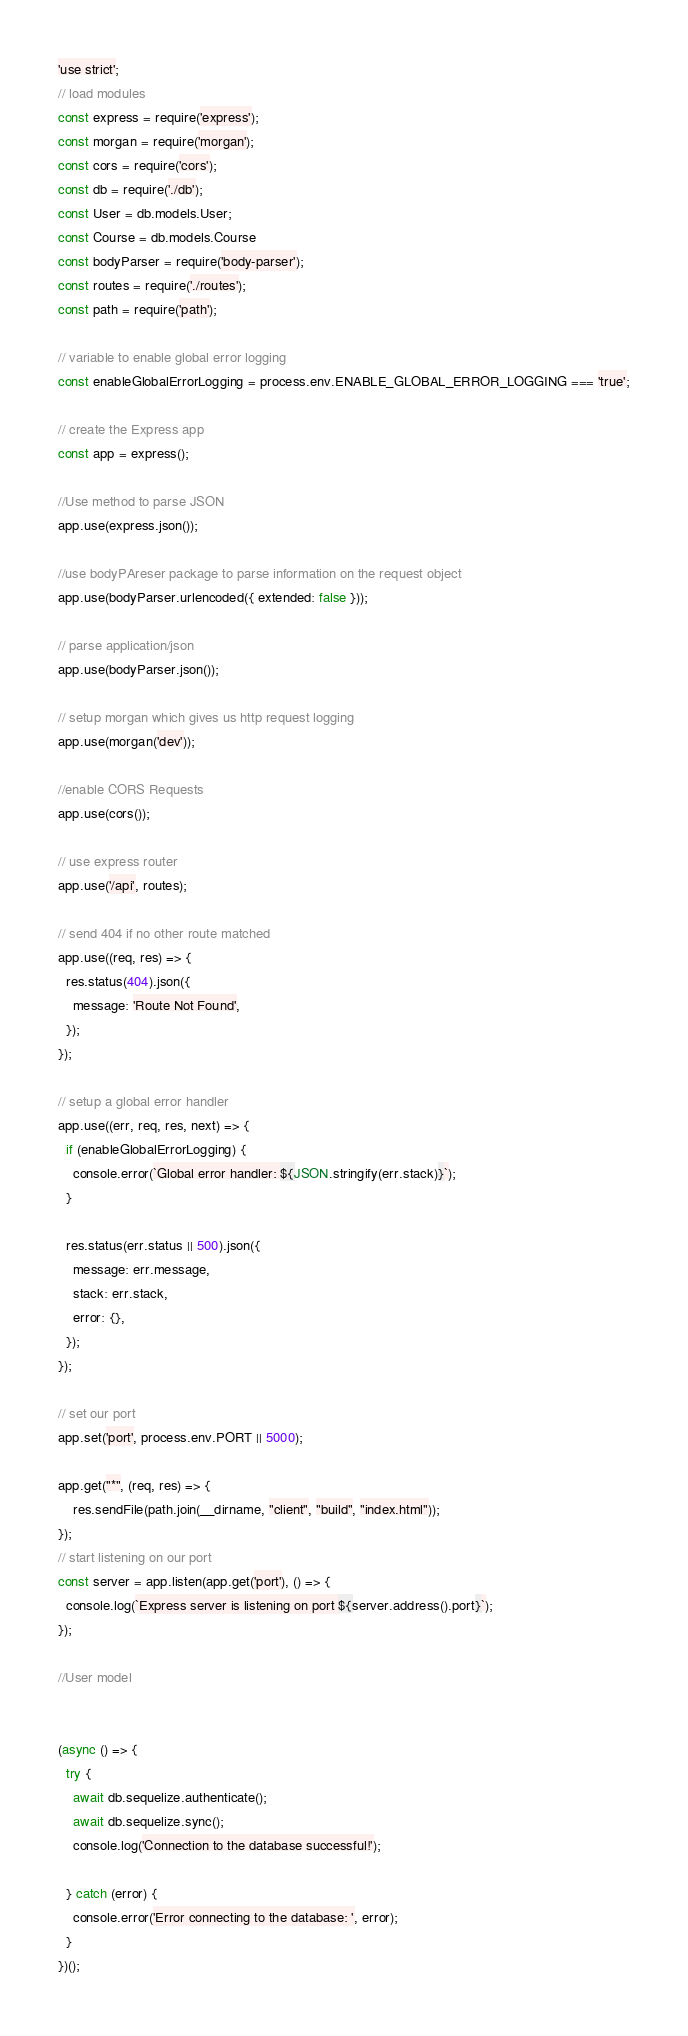<code> <loc_0><loc_0><loc_500><loc_500><_JavaScript_>'use strict';
// load modules
const express = require('express');
const morgan = require('morgan');
const cors = require('cors');
const db = require('./db');
const User = db.models.User;
const Course = db.models.Course
const bodyParser = require('body-parser');
const routes = require('./routes');
const path = require('path');

// variable to enable global error logging
const enableGlobalErrorLogging = process.env.ENABLE_GLOBAL_ERROR_LOGGING === 'true';

// create the Express app
const app = express();

//Use method to parse JSON
app.use(express.json());

//use bodyPAreser package to parse information on the request object
app.use(bodyParser.urlencoded({ extended: false }));

// parse application/json
app.use(bodyParser.json());

// setup morgan which gives us http request logging
app.use(morgan('dev'));

//enable CORS Requests
app.use(cors());

// use express router
app.use('/api', routes);

// send 404 if no other route matched
app.use((req, res) => {
  res.status(404).json({
    message: 'Route Not Found',
  });
});

// setup a global error handler
app.use((err, req, res, next) => {
  if (enableGlobalErrorLogging) {
    console.error(`Global error handler: ${JSON.stringify(err.stack)}`);
  }

  res.status(err.status || 500).json({
    message: err.message,
    stack: err.stack,
    error: {},
  });
});

// set our port
app.set('port', process.env.PORT || 5000);

app.get("*", (req, res) => {
    res.sendFile(path.join(__dirname, "client", "build", "index.html"));
});
// start listening on our port
const server = app.listen(app.get('port'), () => {
  console.log(`Express server is listening on port ${server.address().port}`);
});

//User model


(async () => {
  try {
    await db.sequelize.authenticate();
    await db.sequelize.sync();
    console.log('Connection to the database successful!');

  } catch (error) {
    console.error('Error connecting to the database: ', error);
  }
})();
</code> 